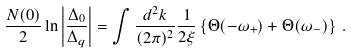Convert formula to latex. <formula><loc_0><loc_0><loc_500><loc_500>\frac { N ( 0 ) } { 2 } \ln \left | \frac { \Delta _ { 0 } } { \Delta _ { q } } \right | = \int \frac { d ^ { 2 } k } { ( 2 \pi ) ^ { 2 } } \frac { 1 } { 2 \xi } \left \{ \Theta ( - \omega _ { + } ) + \Theta ( \omega _ { - } ) \right \} \, .</formula> 